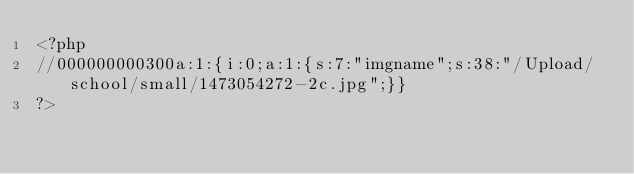<code> <loc_0><loc_0><loc_500><loc_500><_PHP_><?php
//000000000300a:1:{i:0;a:1:{s:7:"imgname";s:38:"/Upload/school/small/1473054272-2c.jpg";}}
?></code> 